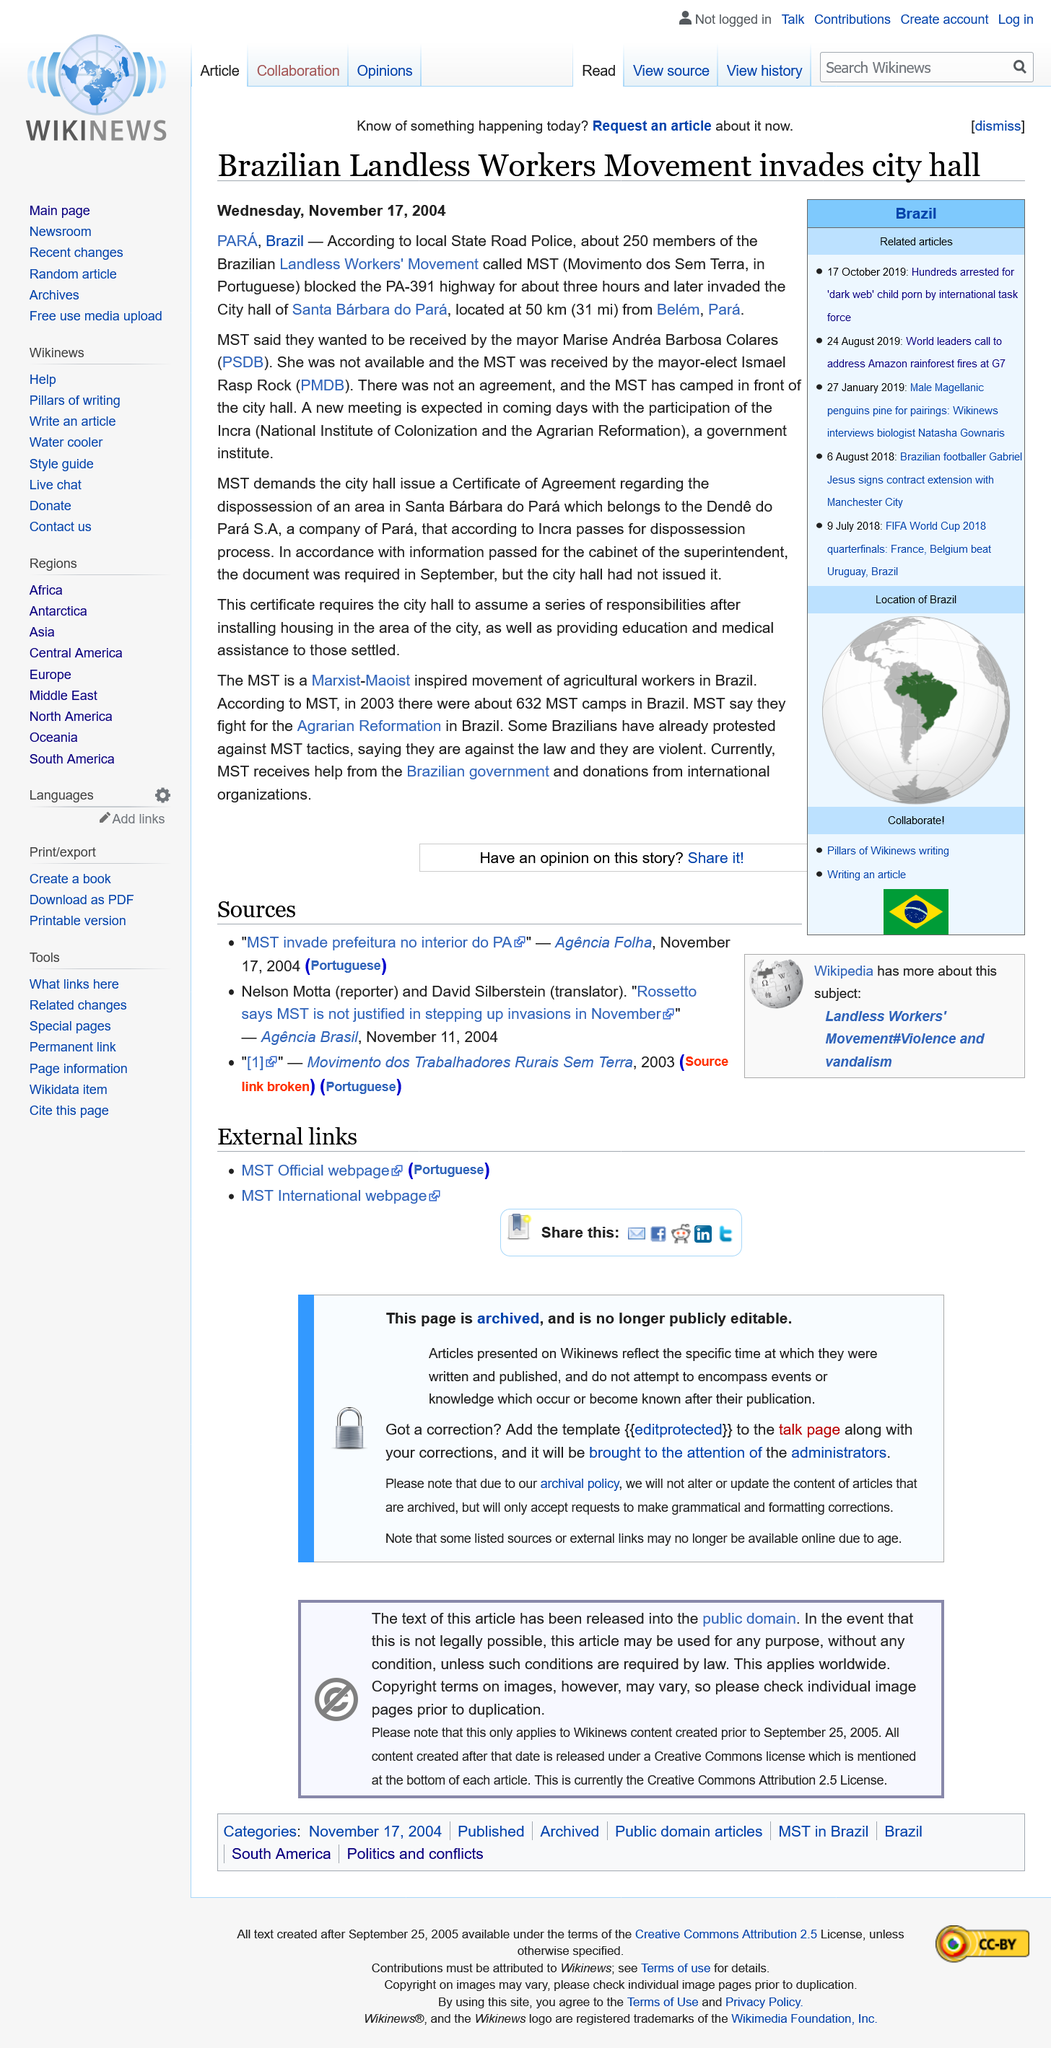Outline some significant characteristics in this image. In 2004, the situation occurred in the state of Pará in Brazil. The Minneapolis-St. Paul International Airport's MST (Multi-Story Terminal) blocked the highway for about 3 hours. On May 22, 2022, a group of around 250 members of the Movement of Brazil's Indigenous People (MST) blocked the PA-391 highway in the state of Mato Grosso do Sul, in protest against the expansion of agricultural activities in indigenous territories and the assassination of indigenous leader and MST member Sonia Guajaja. 